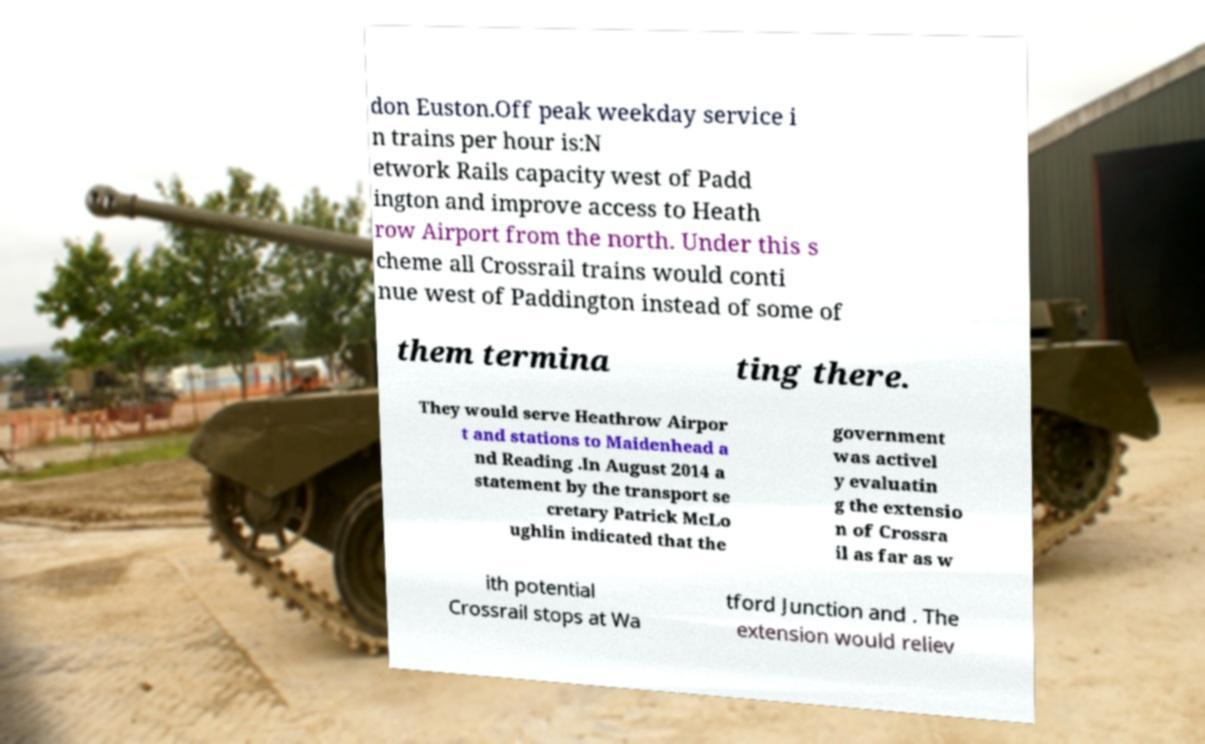Can you read and provide the text displayed in the image?This photo seems to have some interesting text. Can you extract and type it out for me? don Euston.Off peak weekday service i n trains per hour is:N etwork Rails capacity west of Padd ington and improve access to Heath row Airport from the north. Under this s cheme all Crossrail trains would conti nue west of Paddington instead of some of them termina ting there. They would serve Heathrow Airpor t and stations to Maidenhead a nd Reading .In August 2014 a statement by the transport se cretary Patrick McLo ughlin indicated that the government was activel y evaluatin g the extensio n of Crossra il as far as w ith potential Crossrail stops at Wa tford Junction and . The extension would reliev 